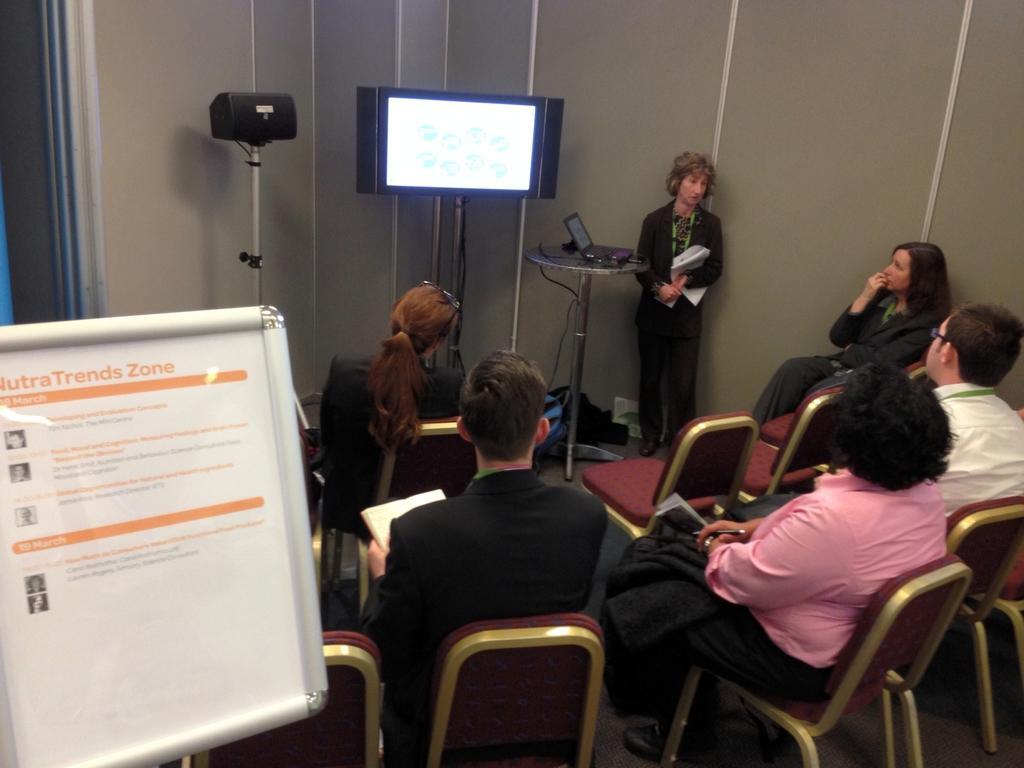Describe this image in one or two sentences. This is a view inside the room. On the left side of the image there is a board. In this room few people are sitting on the chairs and looking at the screen which is at one corner of the room. Beside the screen there is a person standing and holding some papers in hands. 